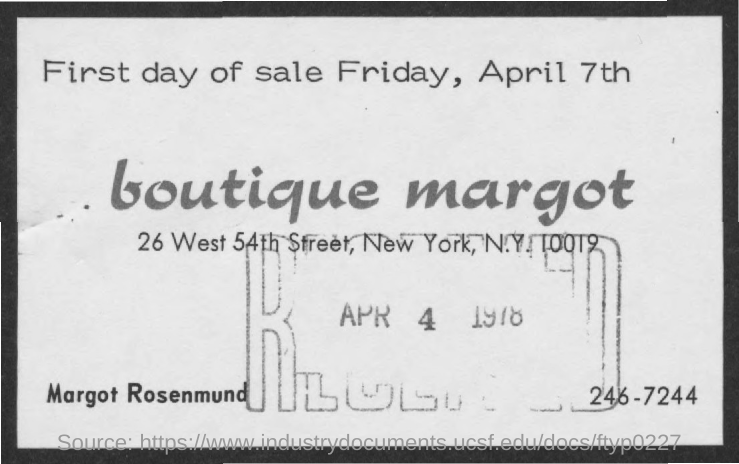List a handful of essential elements in this visual. The location of New York is in a city. The first day of sale will be on Friday, April 7th. The boutique named "Boutique Margot" is the one being referred to. 